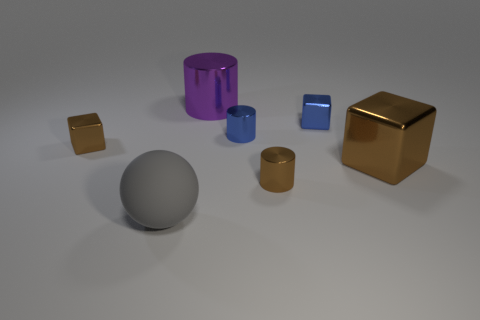What shape is the large metallic object behind the large brown cube?
Offer a terse response. Cylinder. How many purple objects are either large matte cylinders or metal cylinders?
Offer a terse response. 1. There is a large block that is the same material as the tiny blue cylinder; what is its color?
Give a very brief answer. Brown. Do the big shiny cube and the small shiny cube to the left of the tiny blue cube have the same color?
Your answer should be compact. Yes. The cube that is in front of the small blue cylinder and on the right side of the blue shiny cylinder is what color?
Ensure brevity in your answer.  Brown. There is a large rubber object; what number of tiny brown metallic cylinders are behind it?
Provide a succinct answer. 1. What number of objects are small yellow metallic things or large things that are in front of the tiny brown block?
Provide a succinct answer. 2. Are there any small metal things on the right side of the tiny object that is behind the tiny blue metal cylinder?
Your response must be concise. No. What is the color of the cylinder on the left side of the tiny blue cylinder?
Offer a terse response. Purple. Are there the same number of brown metal objects to the right of the small brown metal block and big brown metal objects?
Provide a succinct answer. No. 